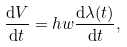Convert formula to latex. <formula><loc_0><loc_0><loc_500><loc_500>\frac { \mathrm d V } { \mathrm d t } = h w \frac { \mathrm d \lambda ( t ) } { \mathrm d t } ,</formula> 